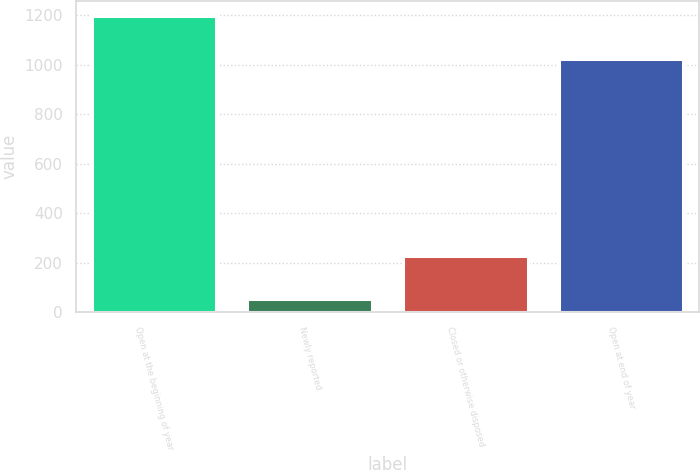Convert chart. <chart><loc_0><loc_0><loc_500><loc_500><bar_chart><fcel>Open at the beginning of year<fcel>Newly reported<fcel>Closed or otherwise disposed<fcel>Open at end of year<nl><fcel>1198<fcel>54<fcel>229<fcel>1023<nl></chart> 